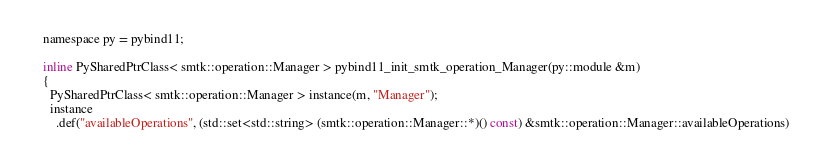<code> <loc_0><loc_0><loc_500><loc_500><_C_>namespace py = pybind11;

inline PySharedPtrClass< smtk::operation::Manager > pybind11_init_smtk_operation_Manager(py::module &m)
{
  PySharedPtrClass< smtk::operation::Manager > instance(m, "Manager");
  instance
    .def("availableOperations", (std::set<std::string> (smtk::operation::Manager::*)() const) &smtk::operation::Manager::availableOperations)</code> 